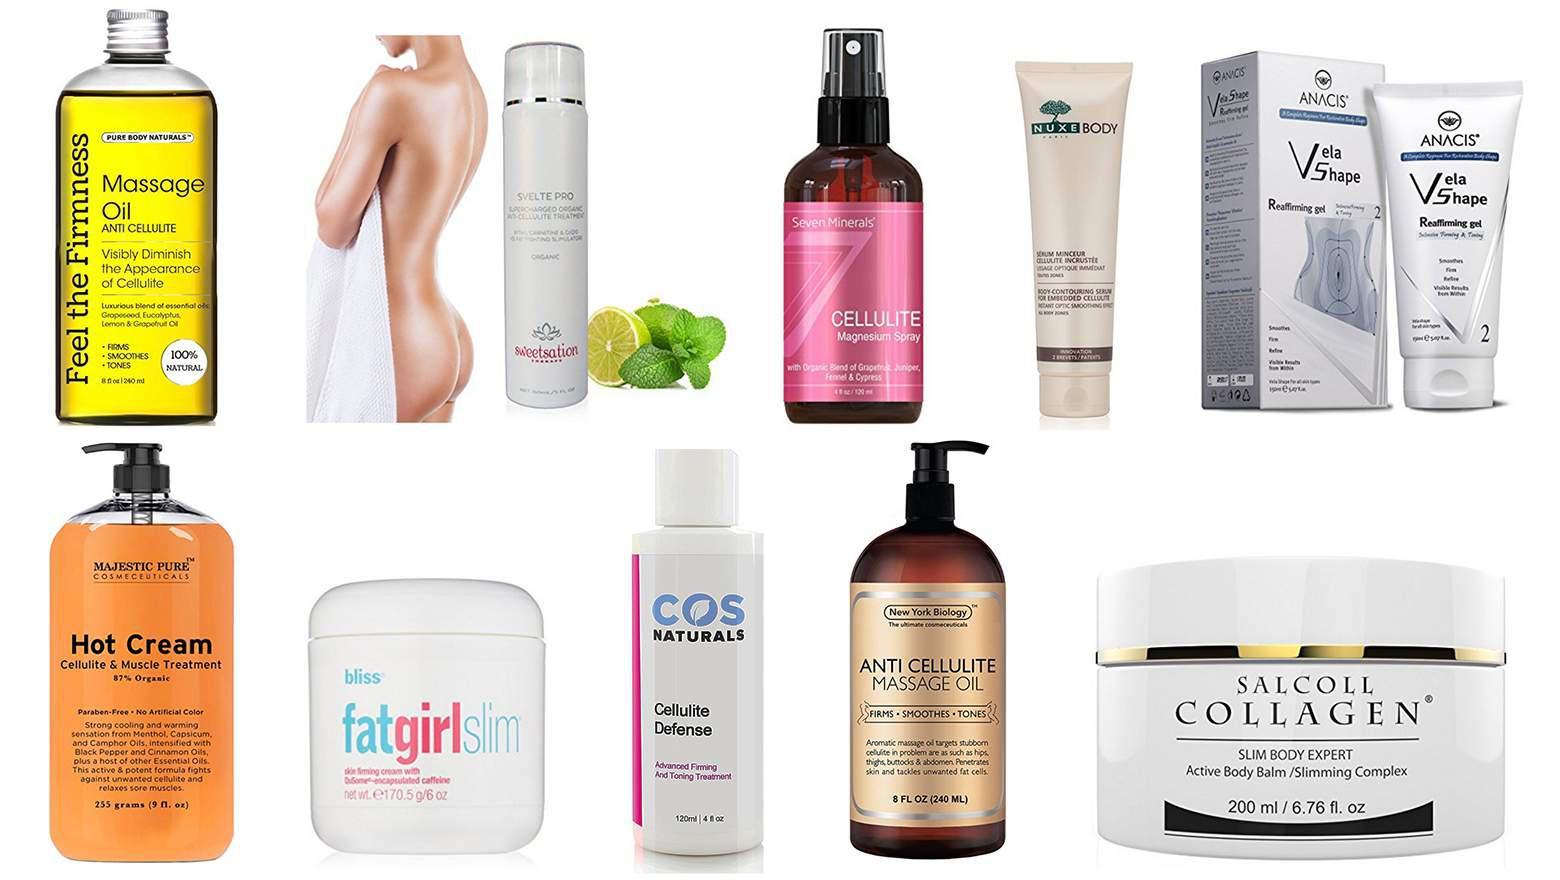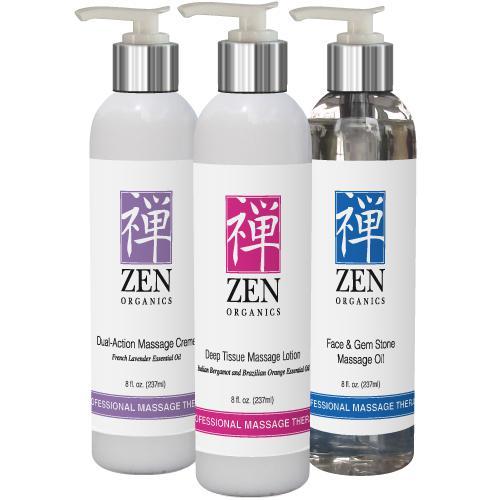The first image is the image on the left, the second image is the image on the right. Analyze the images presented: Is the assertion "Part of the human body is visible in one of the images." valid? Answer yes or no. Yes. 